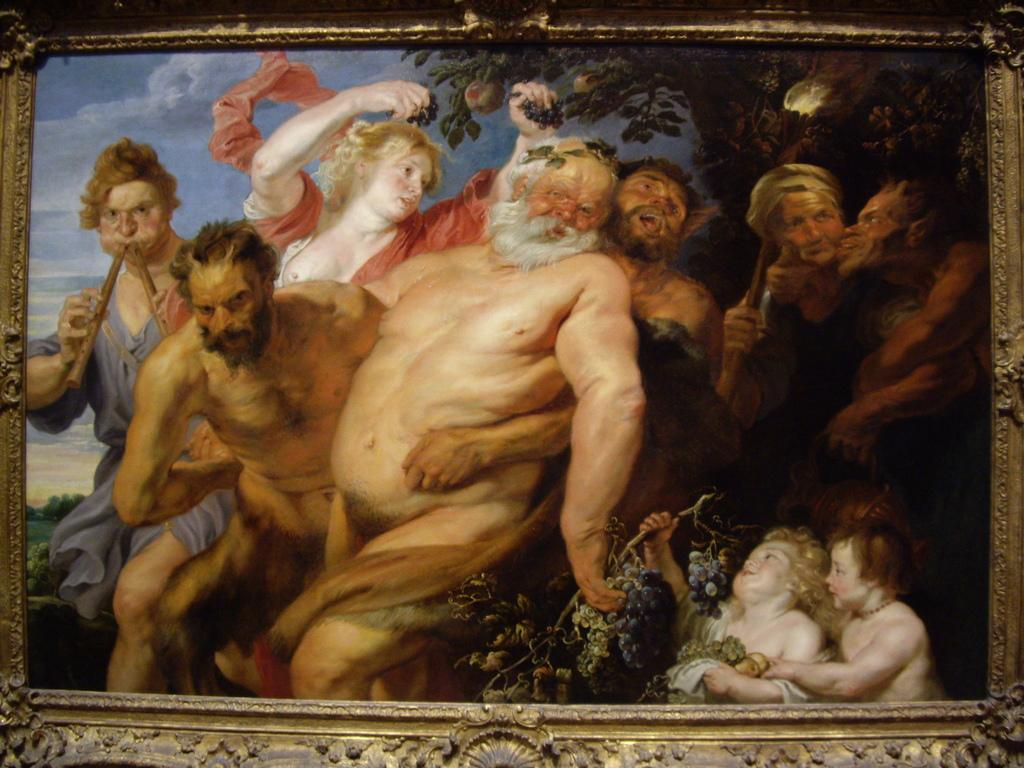What type of object is the image? The image is a photo frame. What can be seen in the photo inside the frame? There are people standing in the photo, including kids at the bottom. What type of fruit is visible in the photo? Grapes are visible in the photo. What type of natural scenery is visible in the background of the photo? There are trees and the sky visible in the background of the photo. Are the people in the photo wearing masks? There is no mention of masks in the image, so we cannot determine if the people are wearing them. Where did the people in the photo go on their trip? The image does not provide information about a trip, so we cannot determine where they went. 